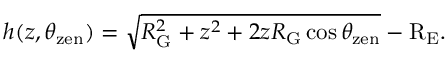Convert formula to latex. <formula><loc_0><loc_0><loc_500><loc_500>h ( z , \theta _ { z e n } ) = \sqrt { R _ { G } ^ { 2 } + z ^ { 2 } + 2 z R _ { G } \cos \theta _ { z e n } } - R _ { E } .</formula> 